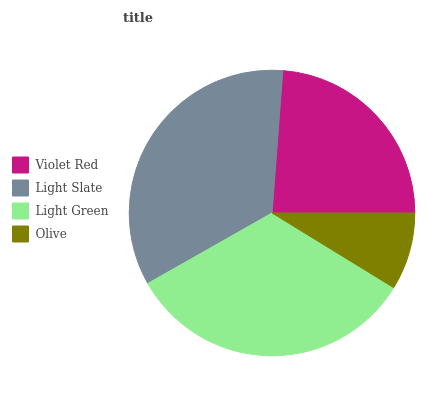Is Olive the minimum?
Answer yes or no. Yes. Is Light Slate the maximum?
Answer yes or no. Yes. Is Light Green the minimum?
Answer yes or no. No. Is Light Green the maximum?
Answer yes or no. No. Is Light Slate greater than Light Green?
Answer yes or no. Yes. Is Light Green less than Light Slate?
Answer yes or no. Yes. Is Light Green greater than Light Slate?
Answer yes or no. No. Is Light Slate less than Light Green?
Answer yes or no. No. Is Light Green the high median?
Answer yes or no. Yes. Is Violet Red the low median?
Answer yes or no. Yes. Is Light Slate the high median?
Answer yes or no. No. Is Light Green the low median?
Answer yes or no. No. 